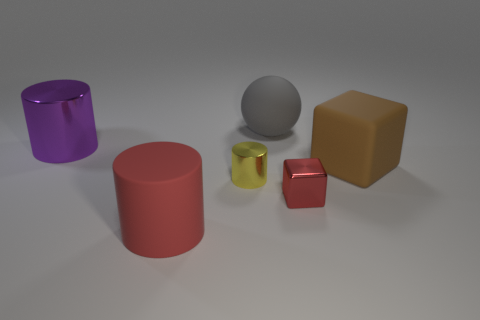Subtract all large matte cylinders. How many cylinders are left? 2 Add 3 brown balls. How many objects exist? 9 Subtract all red cylinders. How many cylinders are left? 2 Subtract 2 cylinders. How many cylinders are left? 1 Add 3 big brown rubber objects. How many big brown rubber objects are left? 4 Add 2 gray spheres. How many gray spheres exist? 3 Subtract 1 brown blocks. How many objects are left? 5 Subtract all cubes. How many objects are left? 4 Subtract all gray blocks. Subtract all red cylinders. How many blocks are left? 2 Subtract all brown spheres. How many brown cylinders are left? 0 